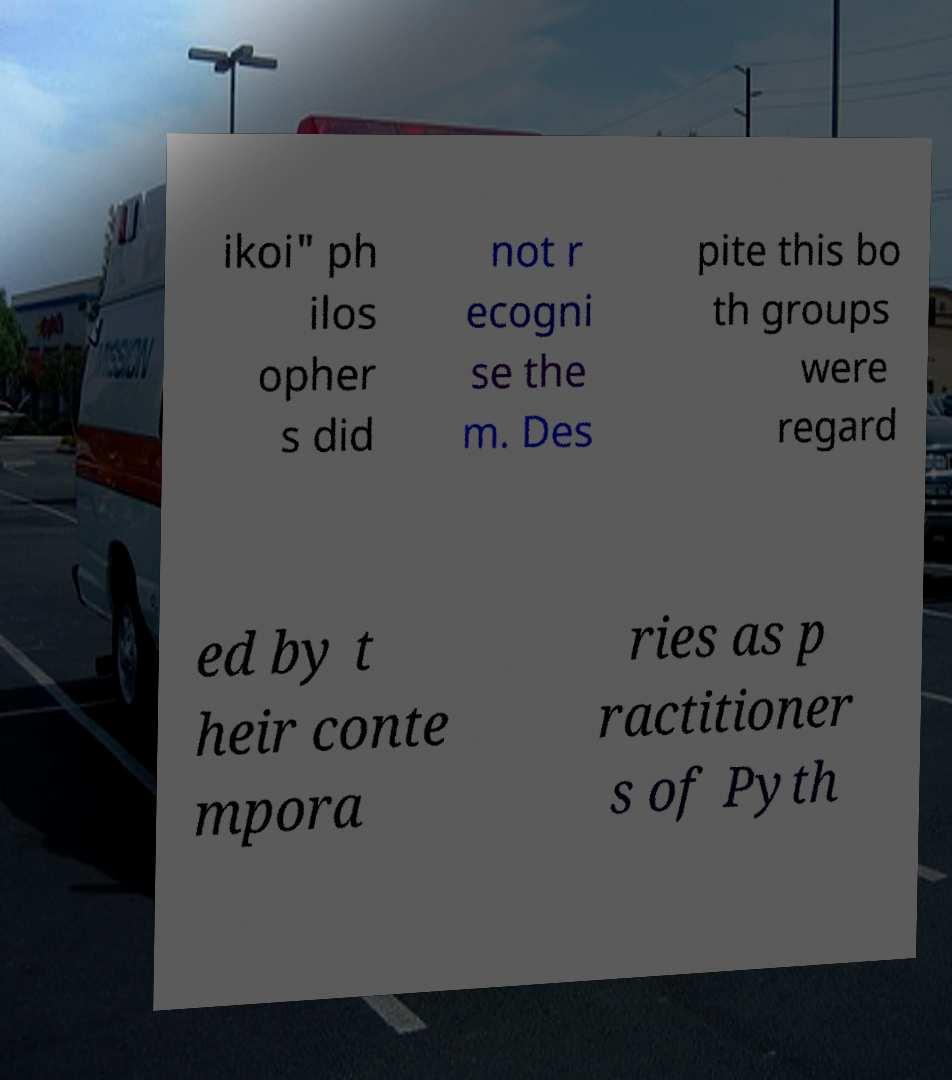Please read and relay the text visible in this image. What does it say? ikoi" ph ilos opher s did not r ecogni se the m. Des pite this bo th groups were regard ed by t heir conte mpora ries as p ractitioner s of Pyth 